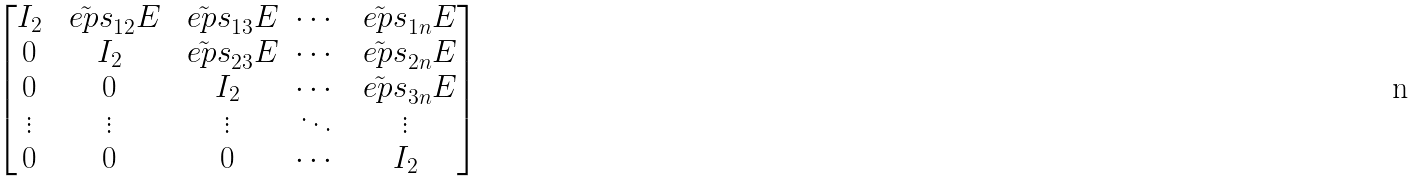Convert formula to latex. <formula><loc_0><loc_0><loc_500><loc_500>\begin{bmatrix} I _ { 2 } & \tilde { \ e p s } _ { 1 2 } E & \tilde { \ e p s } _ { 1 3 } E & \cdots & \tilde { \ e p s } _ { 1 n } E \\ 0 & I _ { 2 } & \tilde { \ e p s } _ { 2 3 } E & \cdots & \tilde { \ e p s } _ { 2 n } E \\ 0 & 0 & I _ { 2 } & \cdots & \tilde { \ e p s } _ { 3 n } E \\ \vdots & \vdots & \vdots & \ddots & \vdots \\ 0 & 0 & 0 & \cdots & I _ { 2 } \end{bmatrix}</formula> 